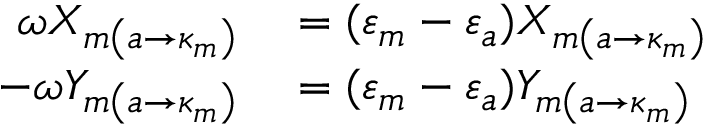<formula> <loc_0><loc_0><loc_500><loc_500>\begin{array} { r l } { \omega X _ { m \left ( a \rightarrow \kappa _ { m } \right ) } } & = ( \varepsilon _ { m } - \varepsilon _ { a } ) X _ { m \left ( a \rightarrow \kappa _ { m } \right ) } } \\ { - \omega Y _ { m \left ( a \rightarrow \kappa _ { m } \right ) } } & = ( \varepsilon _ { m } - \varepsilon _ { a } ) Y _ { m \left ( a \rightarrow \kappa _ { m } \right ) } } \end{array}</formula> 